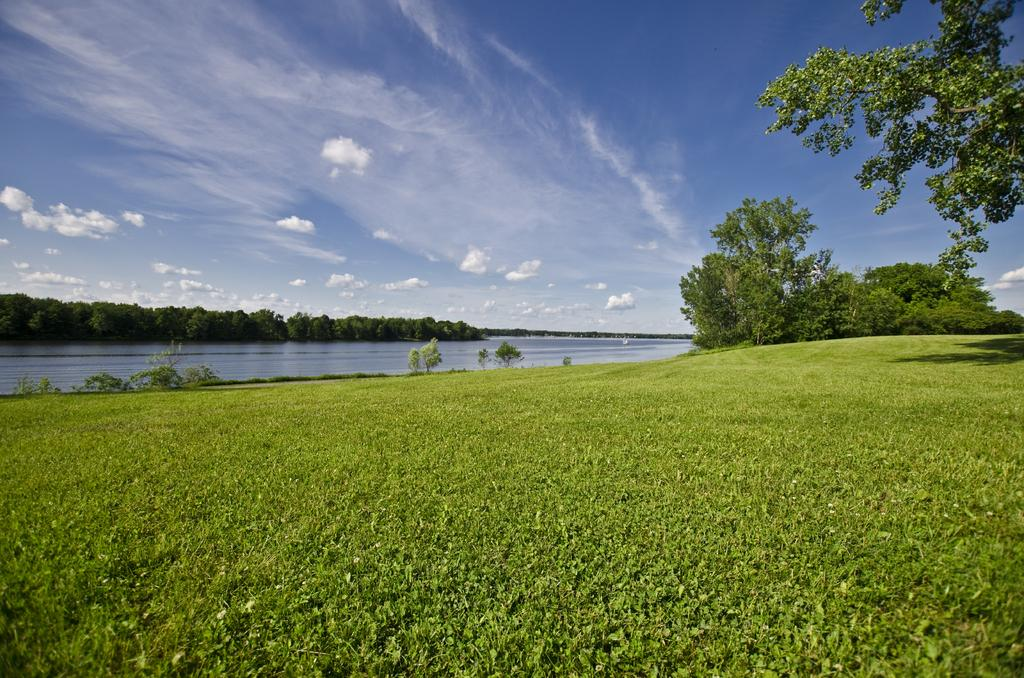What type of ground surface is visible in the image? There is grass on the ground in the image. What other natural elements can be seen in the image? There are trees and plants in the image. What body of water is visible in the image? There is water visible in the image. What is the color of the sky in the image? The sky is blue in the image. What additional feature can be seen in the sky? There are clouds visible in the image. How much money is being exchanged between the trees in the image? There is no money being exchanged between the trees in the image, as trees do not engage in financial transactions. 